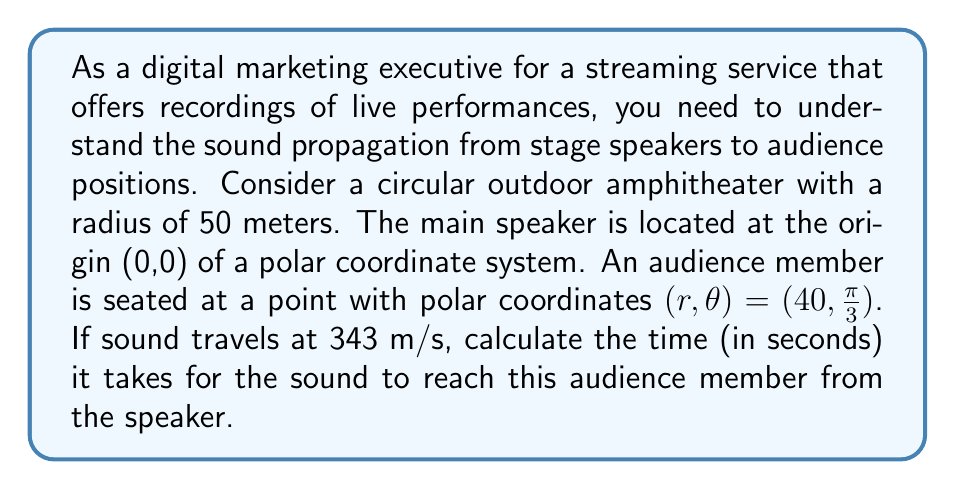Provide a solution to this math problem. To solve this problem, we need to follow these steps:

1) In a polar coordinate system, the distance between two points is given by the radius $r$ when one point is at the origin.

2) In this case, the speaker is at the origin (0,0) and the audience member is at $(r,\theta) = (40, \frac{\pi}{3})$. The distance between them is simply $r = 40$ meters.

3) The formula for the time taken by sound to travel a certain distance is:

   $$t = \frac{d}{v}$$

   Where:
   $t$ is the time in seconds
   $d$ is the distance in meters
   $v$ is the velocity of sound in m/s

4) We know that:
   $d = 40$ meters
   $v = 343$ m/s

5) Substituting these values into the formula:

   $$t = \frac{40}{343}$$

6) Calculating this:

   $$t \approx 0.1166 \text{ seconds}$$

7) Rounding to three decimal places:

   $$t \approx 0.117 \text{ seconds}$$
Answer: The sound will reach the audience member in approximately 0.117 seconds. 